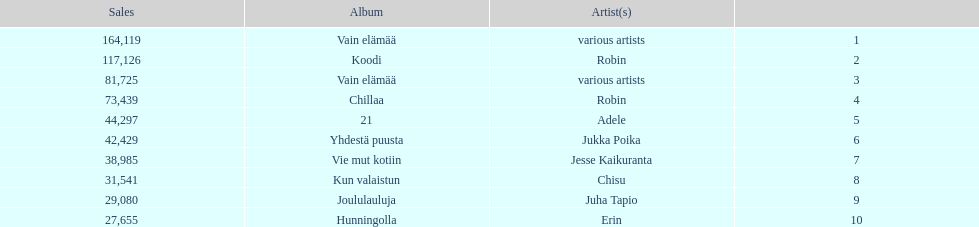Which was better selling, hunningolla or vain elamaa? Vain elämää. 